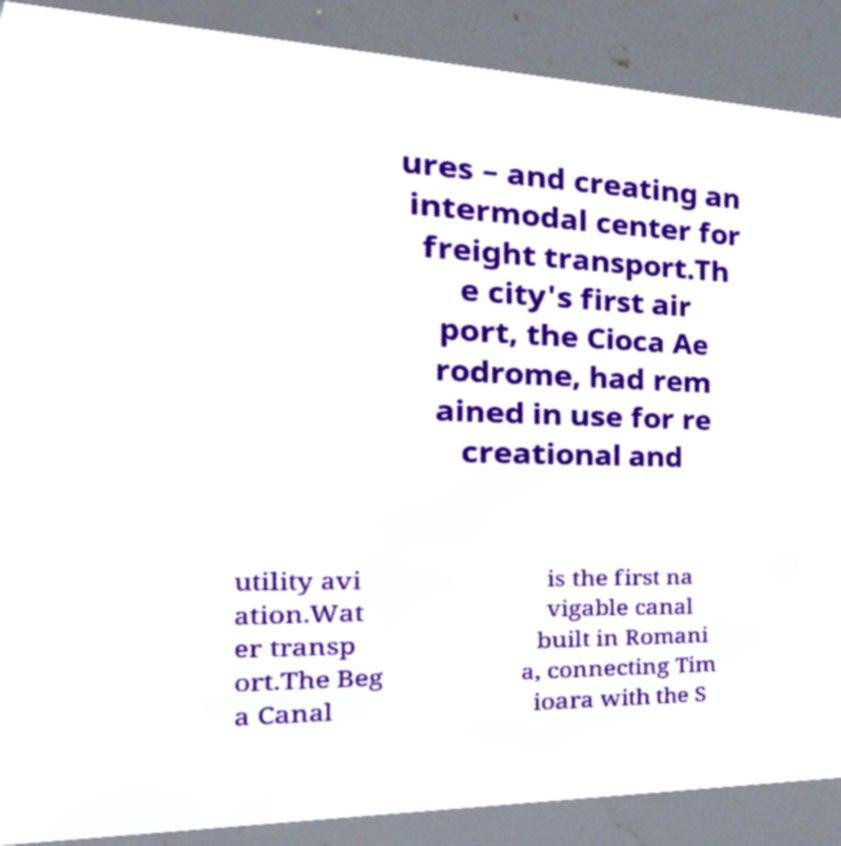Can you accurately transcribe the text from the provided image for me? ures – and creating an intermodal center for freight transport.Th e city's first air port, the Cioca Ae rodrome, had rem ained in use for re creational and utility avi ation.Wat er transp ort.The Beg a Canal is the first na vigable canal built in Romani a, connecting Tim ioara with the S 